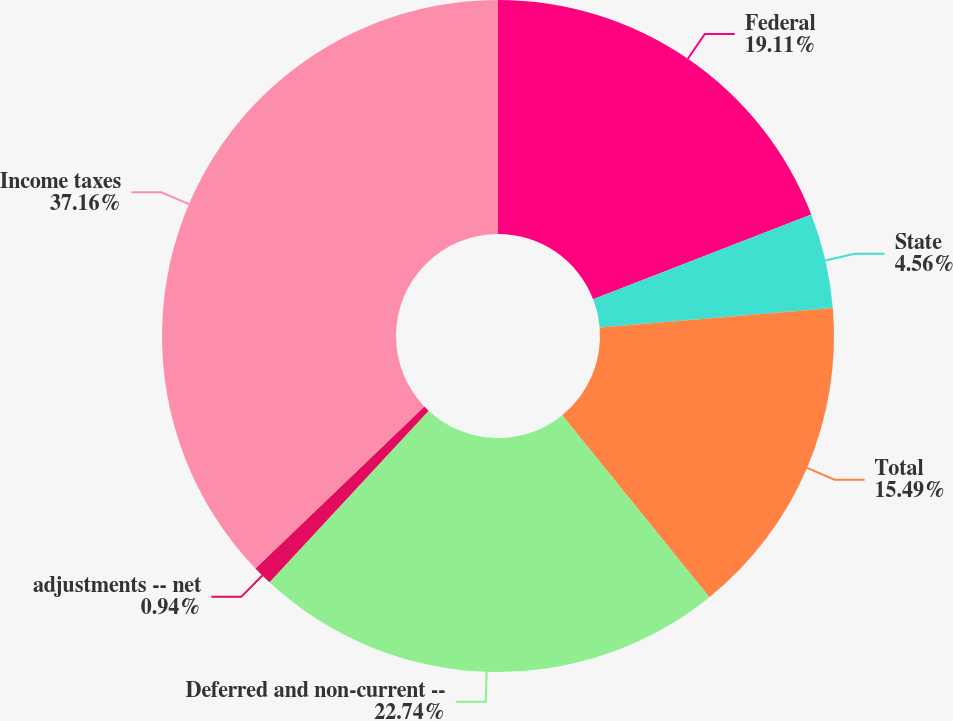Convert chart to OTSL. <chart><loc_0><loc_0><loc_500><loc_500><pie_chart><fcel>Federal<fcel>State<fcel>Total<fcel>Deferred and non-current --<fcel>adjustments -- net<fcel>Income taxes<nl><fcel>19.11%<fcel>4.56%<fcel>15.49%<fcel>22.73%<fcel>0.94%<fcel>37.15%<nl></chart> 